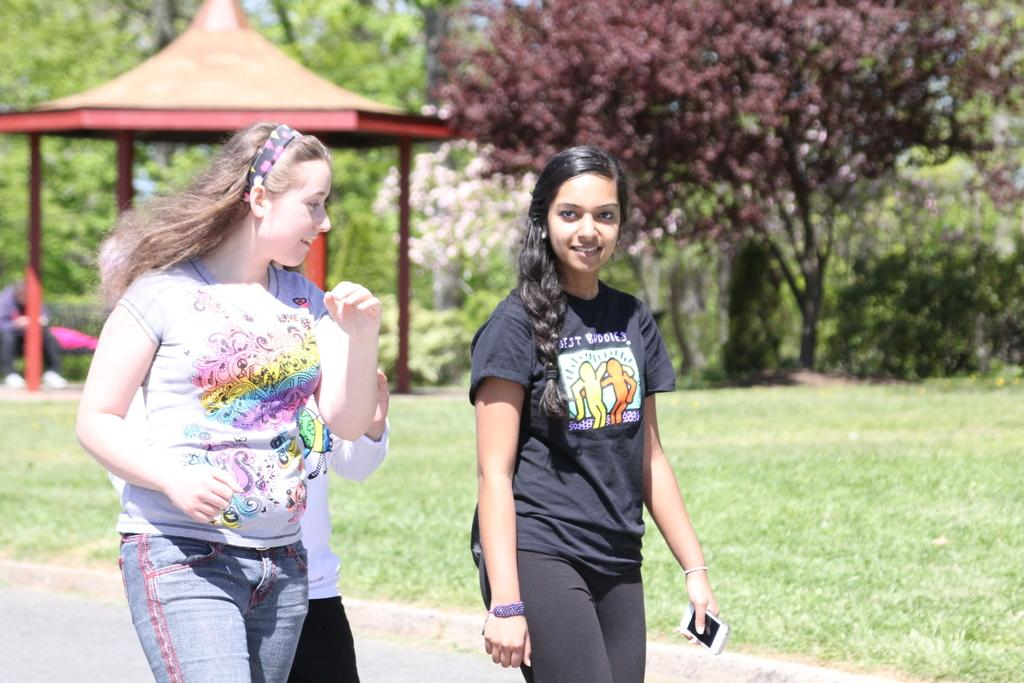How many women are in the image? There are two women in the image. What are the women doing in the image? The women are walking on a road. What can be seen beside the road? There is a ground beside the road. What is present on the ground? Trees and a tent are present on the ground. Where is the person sitting in the image? The person is sitting on a bench on the left side of the image. What type of jeans is the chair wearing in the image? There is no chair present in the image, let alone one wearing jeans. 